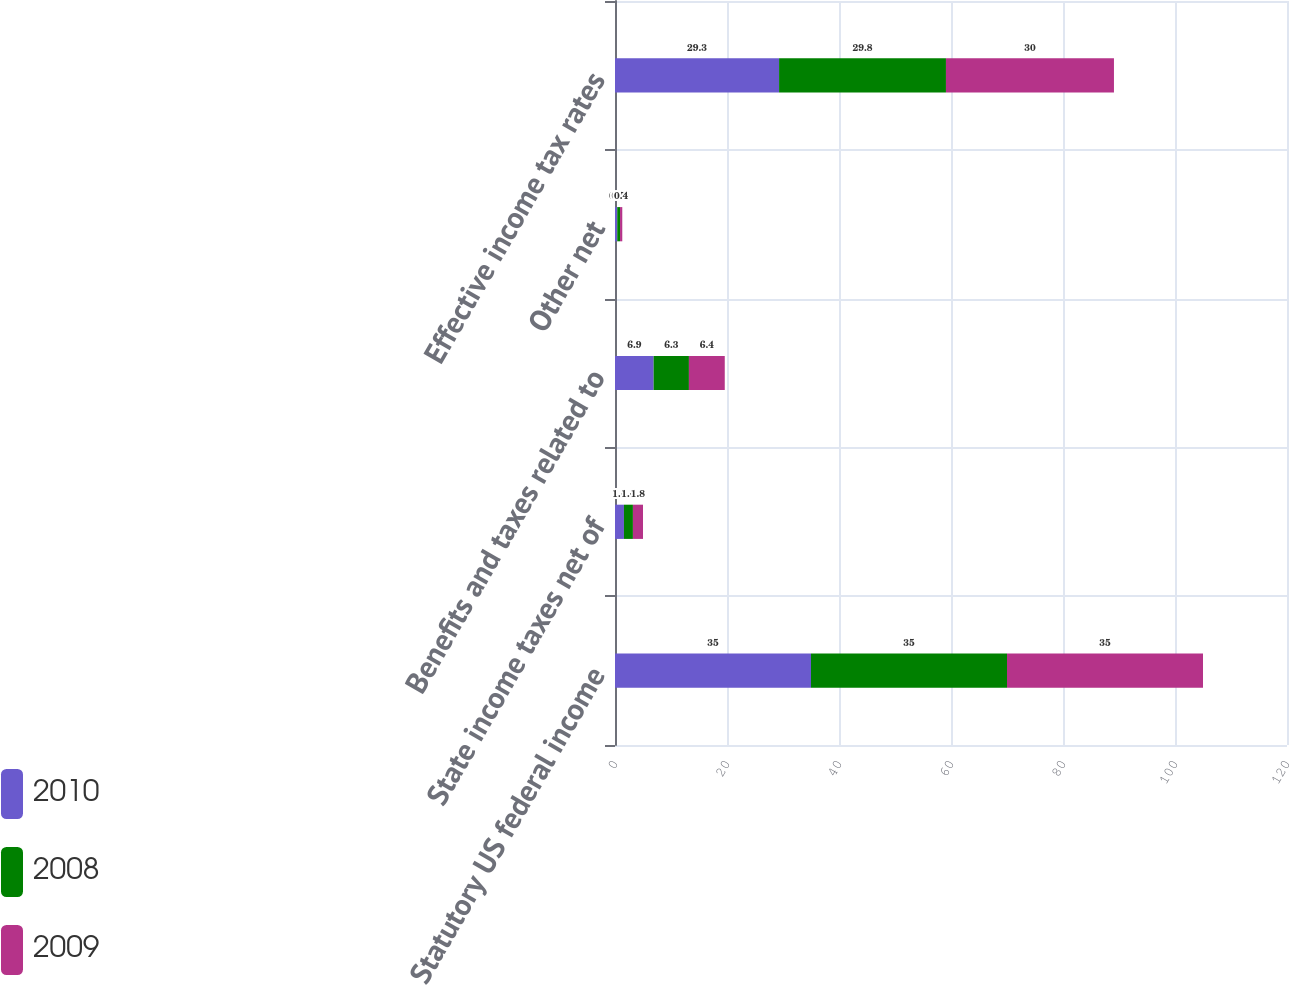<chart> <loc_0><loc_0><loc_500><loc_500><stacked_bar_chart><ecel><fcel>Statutory US federal income<fcel>State income taxes net of<fcel>Benefits and taxes related to<fcel>Other net<fcel>Effective income tax rates<nl><fcel>2010<fcel>35<fcel>1.6<fcel>6.9<fcel>0.4<fcel>29.3<nl><fcel>2008<fcel>35<fcel>1.6<fcel>6.3<fcel>0.5<fcel>29.8<nl><fcel>2009<fcel>35<fcel>1.8<fcel>6.4<fcel>0.4<fcel>30<nl></chart> 